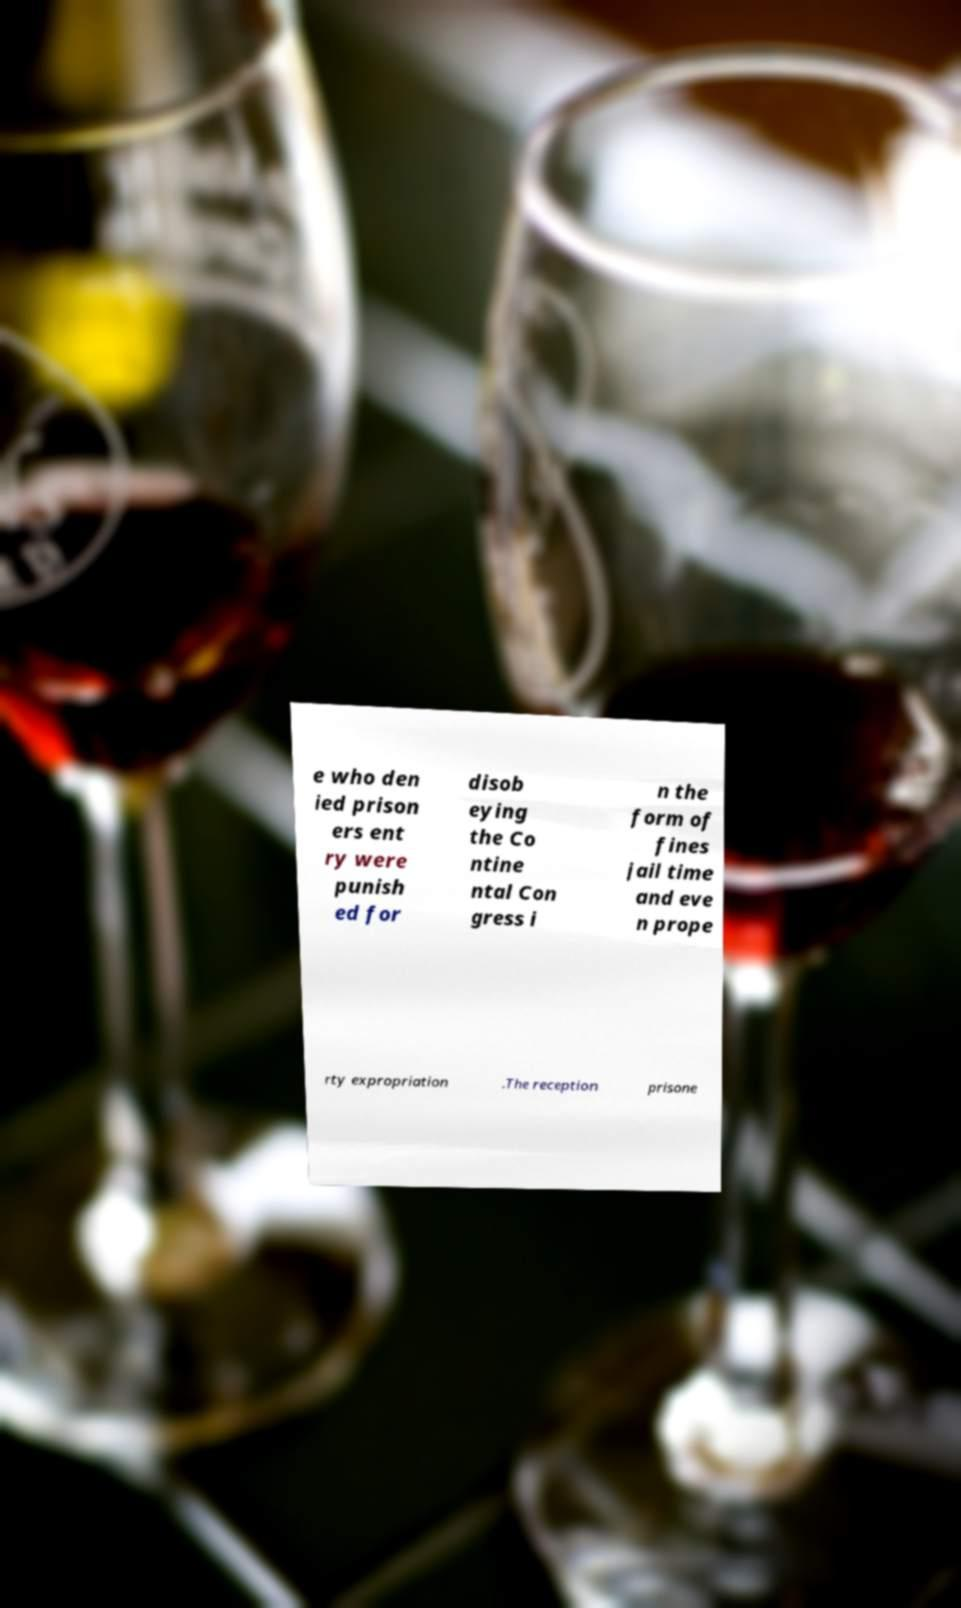What messages or text are displayed in this image? I need them in a readable, typed format. e who den ied prison ers ent ry were punish ed for disob eying the Co ntine ntal Con gress i n the form of fines jail time and eve n prope rty expropriation .The reception prisone 